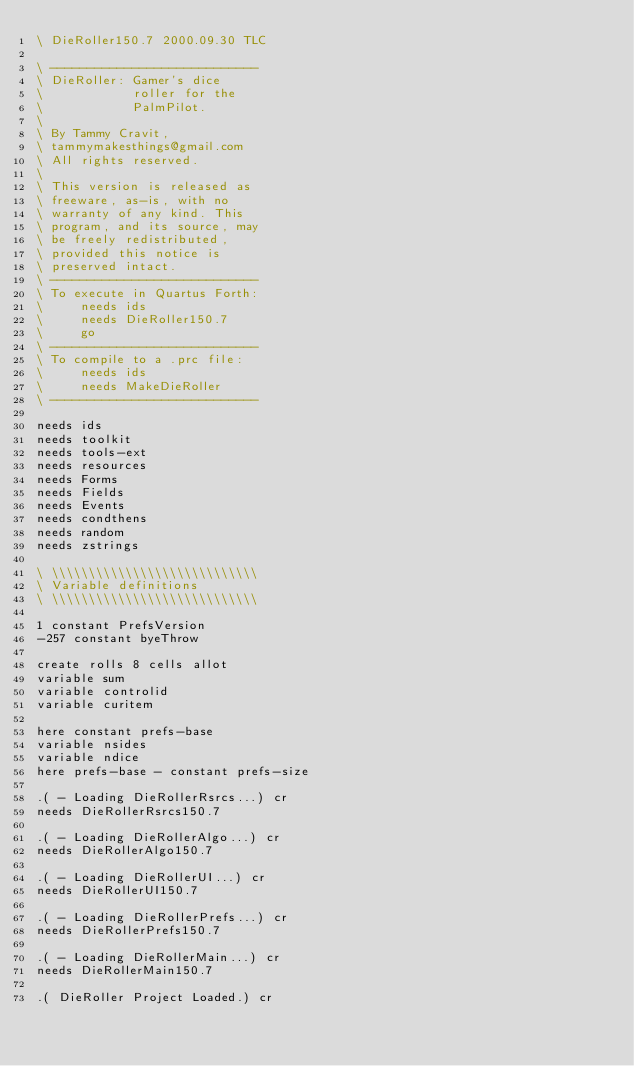Convert code to text. <code><loc_0><loc_0><loc_500><loc_500><_Forth_>\ DieRoller150.7 2000.09.30 TLC

\ ----------------------------
\ DieRoller: Gamer's dice
\            roller for the
\            PalmPilot.
\
\ By Tammy Cravit,
\ tammymakesthings@gmail.com
\ All rights reserved.
\
\ This version is released as
\ freeware, as-is, with no
\ warranty of any kind. This
\ program, and its source, may
\ be freely redistributed,
\ provided this notice is
\ preserved intact.
\ ----------------------------
\ To execute in Quartus Forth:
\     needs ids
\     needs DieRoller150.7
\     go
\ ----------------------------
\ To compile to a .prc file:
\     needs ids
\     needs MakeDieRoller
\ ----------------------------

needs ids
needs toolkit
needs tools-ext
needs resources
needs Forms
needs Fields
needs Events
needs condthens
needs random
needs zstrings

\ \\\\\\\\\\\\\\\\\\\\\\\\\\\\
\ Variable definitions
\ \\\\\\\\\\\\\\\\\\\\\\\\\\\\

1 constant PrefsVersion
-257 constant byeThrow

create rolls 8 cells allot
variable sum
variable controlid
variable curitem

here constant prefs-base
variable nsides
variable ndice
here prefs-base - constant prefs-size

.( - Loading DieRollerRsrcs...) cr
needs DieRollerRsrcs150.7

.( - Loading DieRollerAlgo...) cr
needs DieRollerAlgo150.7

.( - Loading DieRollerUI...) cr
needs DieRollerUI150.7

.( - Loading DieRollerPrefs...) cr
needs DieRollerPrefs150.7

.( - Loading DieRollerMain...) cr
needs DieRollerMain150.7

.( DieRoller Project Loaded.) cr

</code> 